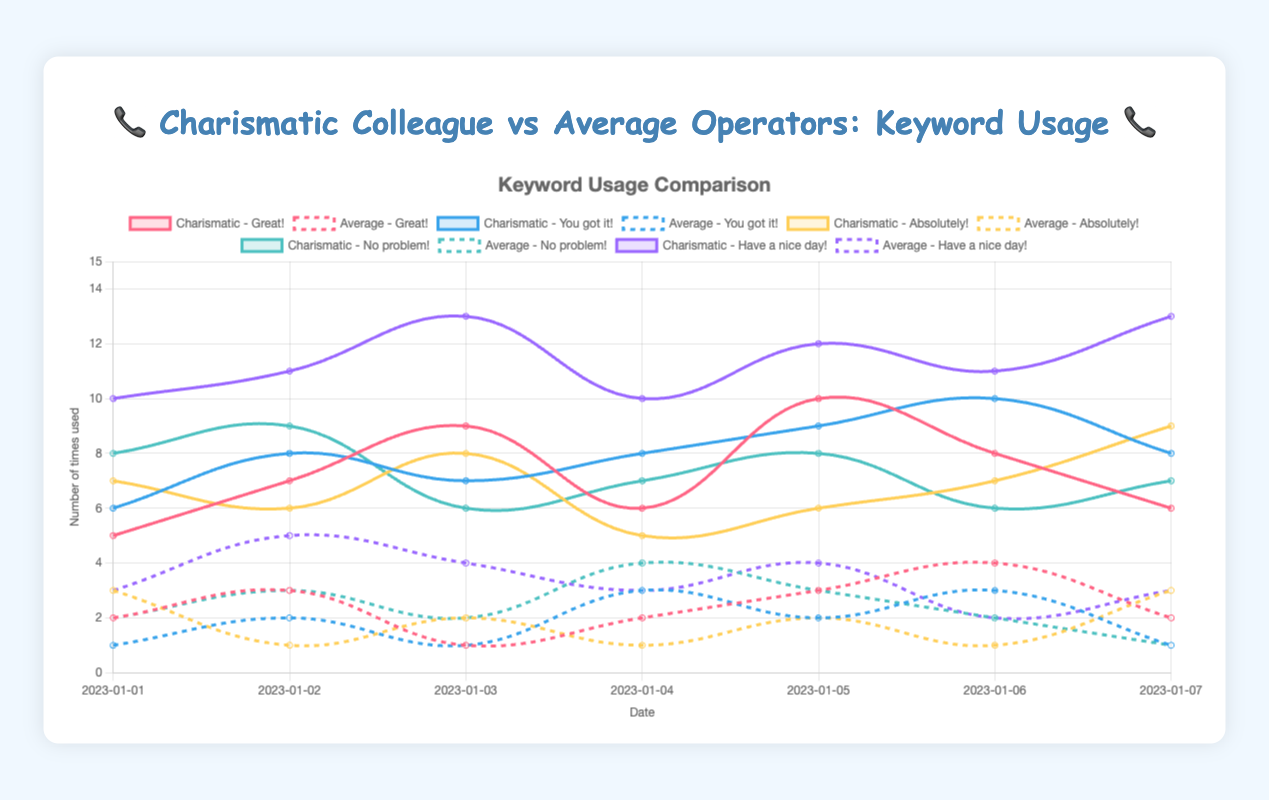Which keyword does the charismatic colleague use the most overall? To find this, we need to look at the total frequency of each keyword used by the charismatic colleague across the entire date range. Summing up the frequencies for "Great!" (5+7+9+6+10+8+6=51), "You got it!" (6+8+7+8+9+10+8=56), "Absolutely!" (7+6+8+5+6+7+9=48), "No problem!" (8+9+6+7+8+6+7=51), and "Have a nice day!" (10+11+13+10+12+11+13=80), we can see that "Have a nice day!" has the highest total frequency.
Answer: Have a nice day! Which keyword shows the largest difference in usage between the charismatic colleague and average operators on the final date? We need to compare the usage of each keyword by both groups on 2023-01-07 and determine the differences: "Great!" (6 - 2 = 4), "You got it!" (8 - 1 = 7), "Absolutely!" (9 - 3 = 6), "No problem!" (7 - 1 = 6), "Have a nice day!" (13 - 3 = 10). The largest difference is for "Have a nice day!" with a difference of 10.
Answer: Have a nice day! Which day had the highest frequency of the keyword "Absolutely!" for the charismatic colleague? We observe the frequency counts for "Absolutely!" used by the charismatic colleague across the given dates: 7, 6, 8, 5, 6, 7, and 9. The highest frequency is 9, which occurs on 2023-01-07.
Answer: 2023-01-07 Which operator group used "You got it!" more consistently over time? Consistency can be evaluated by observing the variability in the line plot for "You got it!" for both groups. The charismatic colleague shows relatively stable usage with values ranging from 6 to 10, while the average operators' usage varies more, ranging from 1 to 3. Therefore, the charismatic colleague used "You got it!" more consistently.
Answer: Charismatic colleague What is the average frequency of "No problem!" used by average operators over the date range? We add the values for "No problem!" (2, 3, 2, 4, 3, 2, 1) and calculate their average: (2 + 3 + 2 + 4 + 3 + 2 + 1) / 7 = 17 / 7 ≈ 2.43.
Answer: 2.43 How does the usage of "Great!" by the charismatic colleague on 2023-01-03 compare to their usage on 2023-01-01? We compare the values for "Great!" on 2023-01-03 (9) and 2023-01-01 (5). 9 is greater than 5, so the frequency increased by 4.
Answer: Increased by 4 Which keyword exhibits the largest peak usage by the charismatic colleague within the given date range? We inspect the plot for each keyword's peak value by the charismatic colleague: "Great!" (10), "You got it!" (10), "Absolutely!" (9), "No problem!" (9), and "Have a nice day!" (13). The highest peak is 13 for "Have a nice day!".
Answer: Have a nice day! Is there any date where the usage of "Absolutely!" by average operators is higher than that by the charismatic colleague? We compare daily usage of "Absolutely!" between the groups. On 2023-01-01: 3 vs. 7, 2023-01-02: 1 vs. 6, 2023-01-03: 2 vs. 8, 2023-01-04: 1 vs. 5, 2023-01-05: 2 vs. 6, 2023-01-06: 1 vs. 7, 2023-01-07: 3 vs. 9. Average operators never outused the charismatic colleague.
Answer: No What’s the trend in the usage of "Have a nice day!" by the charismatic colleague across the given dates? Observing the plot, we see the usage values for "Have a nice day!" rise initially (10, 11), peak on 2023-01-03 (13), drop on 2023-01-04 (10), and then rise again until a peak on 2023-01-07 (13). The trend shows an overall increase with some fluctuations.
Answer: Overall increase with fluctuations How does the frequency of "Great!" by average operators on 2023-01-06 compare to that on 2023-01-07? We observe the values for "Great!" by average operators on both dates: 4 on 2023-01-06 and 2 on 2023-01-07. The frequency decreased from 4 to 2, a decrease of 2.
Answer: Decreased by 2 